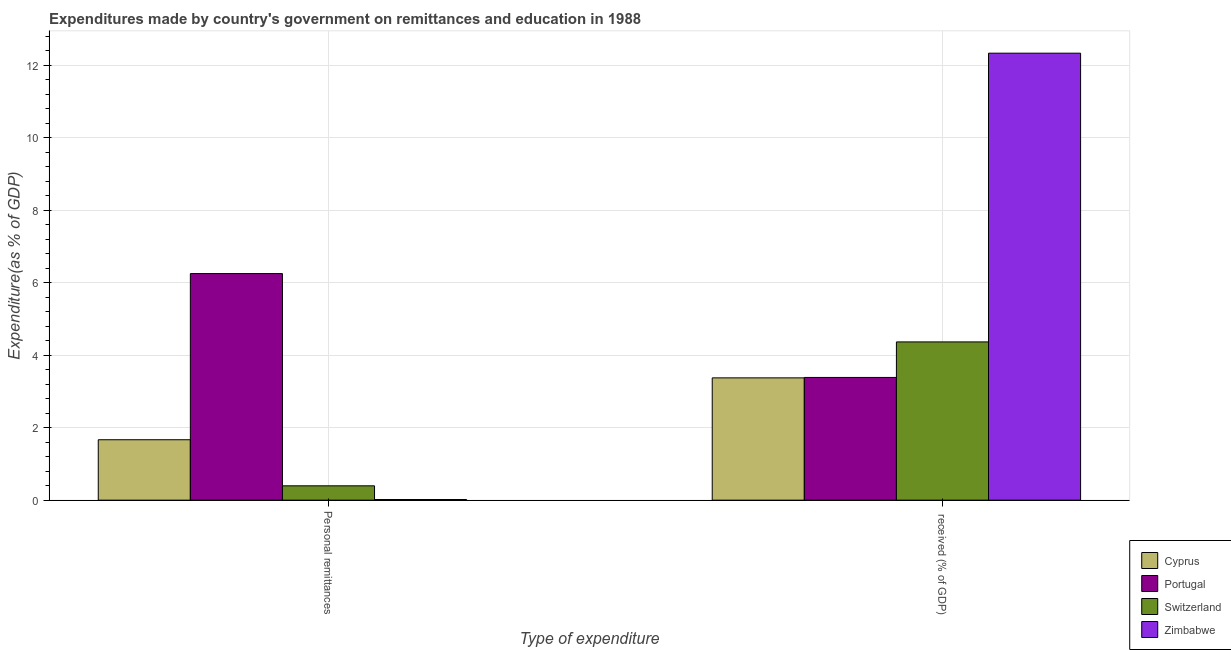How many different coloured bars are there?
Ensure brevity in your answer.  4. Are the number of bars on each tick of the X-axis equal?
Give a very brief answer. Yes. How many bars are there on the 2nd tick from the left?
Your answer should be very brief. 4. What is the label of the 2nd group of bars from the left?
Your answer should be very brief.  received (% of GDP). What is the expenditure in personal remittances in Cyprus?
Your answer should be very brief. 1.67. Across all countries, what is the maximum expenditure in personal remittances?
Offer a very short reply. 6.25. Across all countries, what is the minimum expenditure in personal remittances?
Your response must be concise. 0.02. In which country was the expenditure in education maximum?
Your answer should be very brief. Zimbabwe. In which country was the expenditure in education minimum?
Your answer should be compact. Cyprus. What is the total expenditure in personal remittances in the graph?
Provide a short and direct response. 8.33. What is the difference between the expenditure in education in Cyprus and that in Portugal?
Provide a succinct answer. -0.01. What is the difference between the expenditure in personal remittances in Cyprus and the expenditure in education in Switzerland?
Keep it short and to the point. -2.7. What is the average expenditure in personal remittances per country?
Offer a terse response. 2.08. What is the difference between the expenditure in education and expenditure in personal remittances in Switzerland?
Offer a very short reply. 3.97. What is the ratio of the expenditure in personal remittances in Portugal to that in Cyprus?
Give a very brief answer. 3.75. Is the expenditure in personal remittances in Zimbabwe less than that in Portugal?
Ensure brevity in your answer.  Yes. In how many countries, is the expenditure in personal remittances greater than the average expenditure in personal remittances taken over all countries?
Make the answer very short. 1. What does the 4th bar from the left in  received (% of GDP) represents?
Make the answer very short. Zimbabwe. What does the 1st bar from the right in  received (% of GDP) represents?
Provide a short and direct response. Zimbabwe. Are all the bars in the graph horizontal?
Provide a short and direct response. No. Are the values on the major ticks of Y-axis written in scientific E-notation?
Provide a succinct answer. No. Does the graph contain any zero values?
Keep it short and to the point. No. How many legend labels are there?
Provide a succinct answer. 4. What is the title of the graph?
Give a very brief answer. Expenditures made by country's government on remittances and education in 1988. Does "Sweden" appear as one of the legend labels in the graph?
Your answer should be compact. No. What is the label or title of the X-axis?
Your answer should be compact. Type of expenditure. What is the label or title of the Y-axis?
Provide a succinct answer. Expenditure(as % of GDP). What is the Expenditure(as % of GDP) of Cyprus in Personal remittances?
Provide a succinct answer. 1.67. What is the Expenditure(as % of GDP) of Portugal in Personal remittances?
Keep it short and to the point. 6.25. What is the Expenditure(as % of GDP) of Switzerland in Personal remittances?
Ensure brevity in your answer.  0.4. What is the Expenditure(as % of GDP) in Zimbabwe in Personal remittances?
Keep it short and to the point. 0.02. What is the Expenditure(as % of GDP) of Cyprus in  received (% of GDP)?
Provide a succinct answer. 3.38. What is the Expenditure(as % of GDP) of Portugal in  received (% of GDP)?
Your answer should be very brief. 3.39. What is the Expenditure(as % of GDP) of Switzerland in  received (% of GDP)?
Ensure brevity in your answer.  4.37. What is the Expenditure(as % of GDP) in Zimbabwe in  received (% of GDP)?
Give a very brief answer. 12.34. Across all Type of expenditure, what is the maximum Expenditure(as % of GDP) in Cyprus?
Your response must be concise. 3.38. Across all Type of expenditure, what is the maximum Expenditure(as % of GDP) in Portugal?
Offer a very short reply. 6.25. Across all Type of expenditure, what is the maximum Expenditure(as % of GDP) in Switzerland?
Your answer should be very brief. 4.37. Across all Type of expenditure, what is the maximum Expenditure(as % of GDP) of Zimbabwe?
Give a very brief answer. 12.34. Across all Type of expenditure, what is the minimum Expenditure(as % of GDP) in Cyprus?
Give a very brief answer. 1.67. Across all Type of expenditure, what is the minimum Expenditure(as % of GDP) in Portugal?
Provide a succinct answer. 3.39. Across all Type of expenditure, what is the minimum Expenditure(as % of GDP) in Switzerland?
Your answer should be compact. 0.4. Across all Type of expenditure, what is the minimum Expenditure(as % of GDP) in Zimbabwe?
Provide a short and direct response. 0.02. What is the total Expenditure(as % of GDP) of Cyprus in the graph?
Offer a very short reply. 5.04. What is the total Expenditure(as % of GDP) in Portugal in the graph?
Give a very brief answer. 9.64. What is the total Expenditure(as % of GDP) in Switzerland in the graph?
Your response must be concise. 4.76. What is the total Expenditure(as % of GDP) of Zimbabwe in the graph?
Your response must be concise. 12.36. What is the difference between the Expenditure(as % of GDP) of Cyprus in Personal remittances and that in  received (% of GDP)?
Your answer should be compact. -1.71. What is the difference between the Expenditure(as % of GDP) of Portugal in Personal remittances and that in  received (% of GDP)?
Your response must be concise. 2.87. What is the difference between the Expenditure(as % of GDP) in Switzerland in Personal remittances and that in  received (% of GDP)?
Make the answer very short. -3.97. What is the difference between the Expenditure(as % of GDP) in Zimbabwe in Personal remittances and that in  received (% of GDP)?
Keep it short and to the point. -12.32. What is the difference between the Expenditure(as % of GDP) of Cyprus in Personal remittances and the Expenditure(as % of GDP) of Portugal in  received (% of GDP)?
Make the answer very short. -1.72. What is the difference between the Expenditure(as % of GDP) in Cyprus in Personal remittances and the Expenditure(as % of GDP) in Switzerland in  received (% of GDP)?
Keep it short and to the point. -2.7. What is the difference between the Expenditure(as % of GDP) of Cyprus in Personal remittances and the Expenditure(as % of GDP) of Zimbabwe in  received (% of GDP)?
Offer a terse response. -10.67. What is the difference between the Expenditure(as % of GDP) of Portugal in Personal remittances and the Expenditure(as % of GDP) of Switzerland in  received (% of GDP)?
Make the answer very short. 1.89. What is the difference between the Expenditure(as % of GDP) of Portugal in Personal remittances and the Expenditure(as % of GDP) of Zimbabwe in  received (% of GDP)?
Ensure brevity in your answer.  -6.08. What is the difference between the Expenditure(as % of GDP) in Switzerland in Personal remittances and the Expenditure(as % of GDP) in Zimbabwe in  received (% of GDP)?
Your answer should be compact. -11.94. What is the average Expenditure(as % of GDP) in Cyprus per Type of expenditure?
Ensure brevity in your answer.  2.52. What is the average Expenditure(as % of GDP) of Portugal per Type of expenditure?
Keep it short and to the point. 4.82. What is the average Expenditure(as % of GDP) of Switzerland per Type of expenditure?
Provide a succinct answer. 2.38. What is the average Expenditure(as % of GDP) of Zimbabwe per Type of expenditure?
Offer a terse response. 6.18. What is the difference between the Expenditure(as % of GDP) of Cyprus and Expenditure(as % of GDP) of Portugal in Personal remittances?
Provide a short and direct response. -4.59. What is the difference between the Expenditure(as % of GDP) in Cyprus and Expenditure(as % of GDP) in Switzerland in Personal remittances?
Provide a succinct answer. 1.27. What is the difference between the Expenditure(as % of GDP) in Cyprus and Expenditure(as % of GDP) in Zimbabwe in Personal remittances?
Give a very brief answer. 1.65. What is the difference between the Expenditure(as % of GDP) of Portugal and Expenditure(as % of GDP) of Switzerland in Personal remittances?
Offer a terse response. 5.86. What is the difference between the Expenditure(as % of GDP) of Portugal and Expenditure(as % of GDP) of Zimbabwe in Personal remittances?
Give a very brief answer. 6.24. What is the difference between the Expenditure(as % of GDP) in Switzerland and Expenditure(as % of GDP) in Zimbabwe in Personal remittances?
Offer a terse response. 0.38. What is the difference between the Expenditure(as % of GDP) in Cyprus and Expenditure(as % of GDP) in Portugal in  received (% of GDP)?
Keep it short and to the point. -0.01. What is the difference between the Expenditure(as % of GDP) of Cyprus and Expenditure(as % of GDP) of Switzerland in  received (% of GDP)?
Offer a terse response. -0.99. What is the difference between the Expenditure(as % of GDP) in Cyprus and Expenditure(as % of GDP) in Zimbabwe in  received (% of GDP)?
Your answer should be very brief. -8.96. What is the difference between the Expenditure(as % of GDP) of Portugal and Expenditure(as % of GDP) of Switzerland in  received (% of GDP)?
Keep it short and to the point. -0.98. What is the difference between the Expenditure(as % of GDP) in Portugal and Expenditure(as % of GDP) in Zimbabwe in  received (% of GDP)?
Your answer should be compact. -8.95. What is the difference between the Expenditure(as % of GDP) of Switzerland and Expenditure(as % of GDP) of Zimbabwe in  received (% of GDP)?
Your answer should be compact. -7.97. What is the ratio of the Expenditure(as % of GDP) in Cyprus in Personal remittances to that in  received (% of GDP)?
Provide a short and direct response. 0.49. What is the ratio of the Expenditure(as % of GDP) of Portugal in Personal remittances to that in  received (% of GDP)?
Your response must be concise. 1.85. What is the ratio of the Expenditure(as % of GDP) in Switzerland in Personal remittances to that in  received (% of GDP)?
Offer a very short reply. 0.09. What is the ratio of the Expenditure(as % of GDP) in Zimbabwe in Personal remittances to that in  received (% of GDP)?
Your response must be concise. 0. What is the difference between the highest and the second highest Expenditure(as % of GDP) in Cyprus?
Make the answer very short. 1.71. What is the difference between the highest and the second highest Expenditure(as % of GDP) of Portugal?
Offer a very short reply. 2.87. What is the difference between the highest and the second highest Expenditure(as % of GDP) in Switzerland?
Ensure brevity in your answer.  3.97. What is the difference between the highest and the second highest Expenditure(as % of GDP) of Zimbabwe?
Offer a very short reply. 12.32. What is the difference between the highest and the lowest Expenditure(as % of GDP) of Cyprus?
Provide a short and direct response. 1.71. What is the difference between the highest and the lowest Expenditure(as % of GDP) in Portugal?
Your answer should be compact. 2.87. What is the difference between the highest and the lowest Expenditure(as % of GDP) of Switzerland?
Your response must be concise. 3.97. What is the difference between the highest and the lowest Expenditure(as % of GDP) in Zimbabwe?
Your response must be concise. 12.32. 